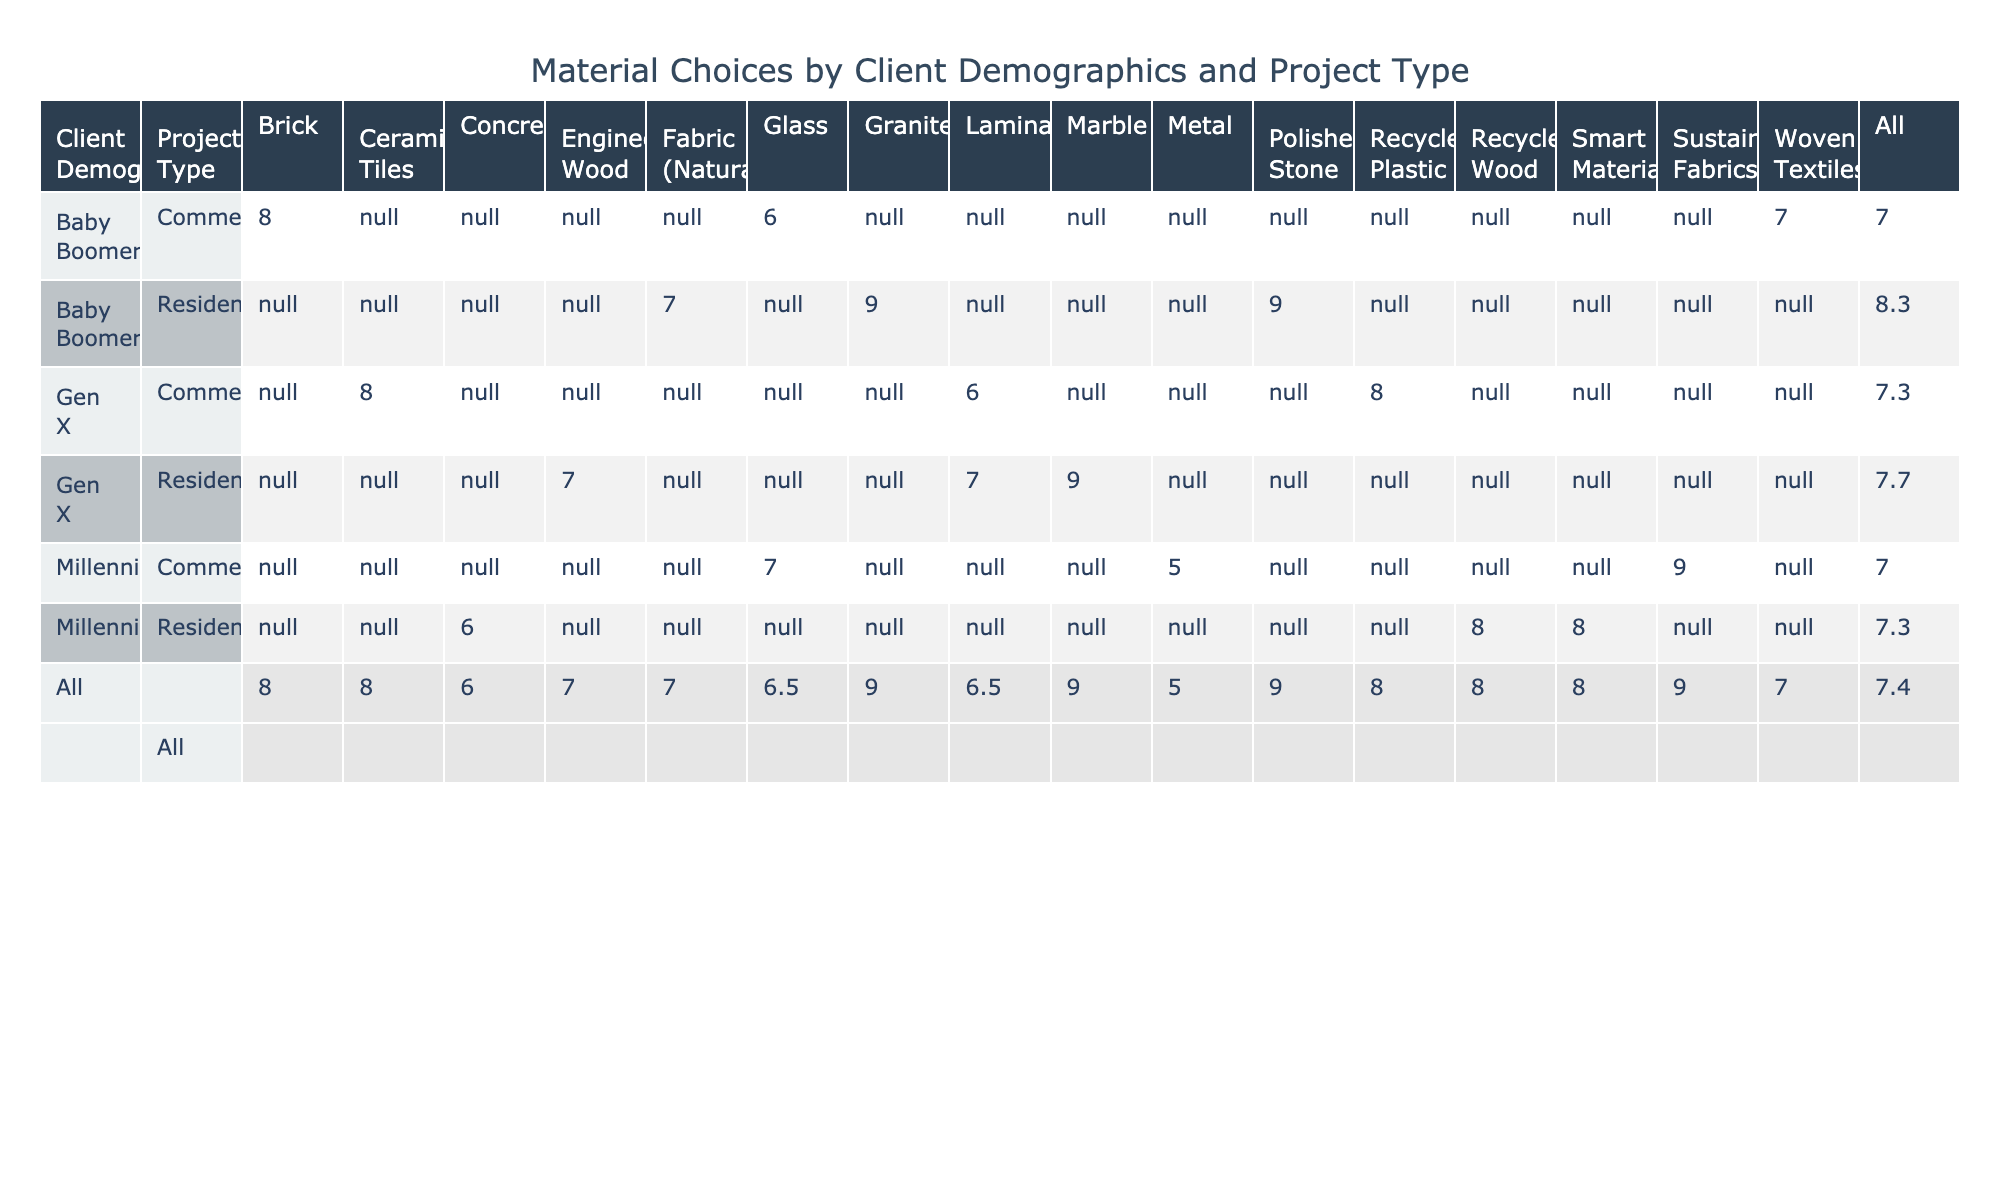What is the highest preference score for Residential projects among Millennials? Looking at the table, the highest preference score for Residential projects from Millennials is for Recycled Wood with a score of 8.
Answer: 8 What material choice has the lowest preference score for Commercial projects among Gen X? The lowest preference score for Commercial projects from Gen X is for Laminate with a score of 6.
Answer: 6 Is the average preference score for Baby Boomers in Residential projects higher than that for Commercial projects? The average preference score for Residential projects among Baby Boomers is (7 + 9 + 9) / 3 = 8.3, while for Commercial projects, it is (8 + 7) / 2 = 7.5. Because 8.3 > 7.5, the answer is yes.
Answer: Yes What is the total preference score for Millennials across all project types? For Millennials, the preference scores are: Residential (Recycled Wood 8, Concrete 6, Smart Materials 8) and Commercial (Glass 7, Metal 5, Sustainable Fabrics 9). Summing these scores gives 8 + 6 + 8 + 7 + 5 + 9 = 43.
Answer: 43 Among Gen X, what is the difference between the highest and lowest preference scores for Residential projects? In Residential projects for Gen X, the highest score is from Marble (9) and the lowest score is from Laminate (7). The difference is 9 - 7 = 2.
Answer: 2 Among all the client demographics, is there a material choice that has the highest score in more than one group? Checking the table, Polished Stone has a preference score of 9 for Baby Boomers in Residential; however, no other group has Polished Stone listed. Hence, the answer is no.
Answer: No What is the average preference score for Commercial projects across all demographics? For Commercial projects, the preference scores are: Gen X (6 + 8), Baby Boomers (8 + 7), and Millennials (7 + 5 + 9). Calculating the average gives (6 + 8 + 8 + 7 + 7 + 5 + 9) / 7 = 7.14, which rounds to 7.1.
Answer: 7.1 What material choice receives the highest preference score among Baby Boomers for Residential projects? In the Residential category for Baby Boomers, both Granite and Polished Stone have a preference score of 9, making them the highest.
Answer: Granite, Polished Stone 